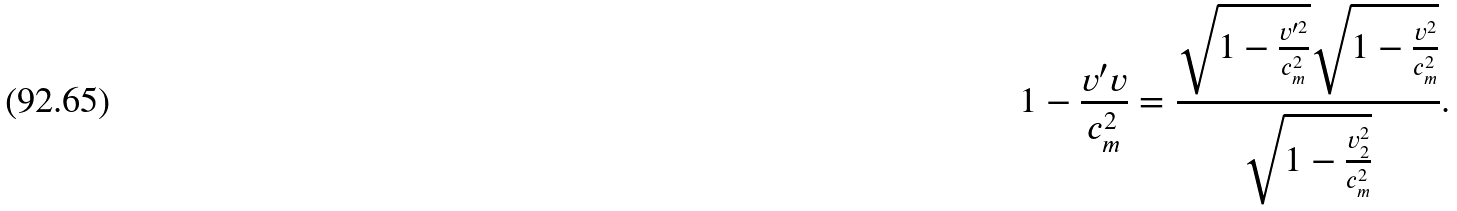Convert formula to latex. <formula><loc_0><loc_0><loc_500><loc_500>1 - \frac { v ^ { \prime } v } { c _ { m } ^ { 2 } } = \frac { \sqrt { 1 - \frac { v ^ { \prime 2 } } { c _ { m } ^ { 2 } } } \sqrt { 1 - \frac { v ^ { 2 } } { c _ { m } ^ { 2 } } } } { \sqrt { 1 - \frac { v _ { 2 } ^ { 2 } } { c _ { m } ^ { 2 } } } } .</formula> 